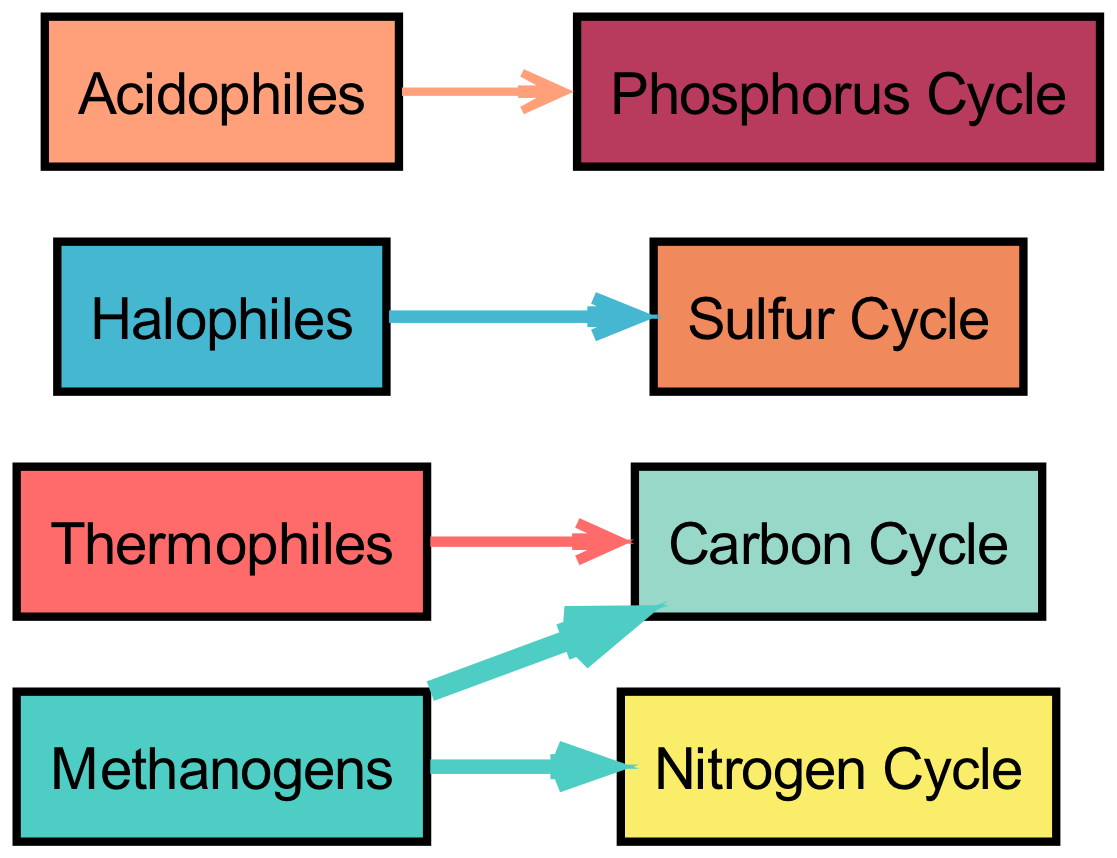What is the total contribution of Methanogens to biogeochemical cycles? The contribution of Methanogens is shown in the diagram as two separate links: 10 for the Carbon Cycle and 7 for the Nitrogen Cycle. Adding these values gives a total contribution of 10 + 7 = 17.
Answer: 17 Which extremophile contributes to the Sulfur Cycle? The diagram indicates that Halophiles directly contribute to the Sulfur Cycle with a value of 6.
Answer: Halophiles How many distinct contributions are made to the Carbon Cycle? From the diagram, there are two sources contributing to the Carbon Cycle: Thermophiles and Methanogens, making it a total of two distinct contributions.
Answer: 2 What is the value of the link from Acidophiles to the Phosphorus Cycle? The diagram specifies that the link from Acidophiles to the Phosphorus Cycle has a value of 4, indicating the strength of this contribution.
Answer: 4 Which extremophile has the highest contribution to the Carbon Cycle? By examining the links, Methanogens contribute 10 to the Carbon Cycle, which is greater than the contribution from Thermophiles, which is only 5. Thus, Methanogens have the highest contribution.
Answer: Methanogens How many edges are there in total connecting extremophiles to cycles? The diagram presents a total of five edges, which represent connections from extremophiles to the various biogeochemical cycles: Thermophiles to Carbon Cycle, Methanogens to Carbon and Nitrogen Cycles, Halophiles to Sulfur Cycle, and Acidophiles to Phosphorus Cycle.
Answer: 5 Which extremophile contributes to the Nitrogen Cycle, and what is the value of this contribution? The link from Methanogens to the Nitrogen Cycle has a value of 7, indicating their contribution to this cycle.
Answer: 7 What is the total contribution of Acidophiles to biogeochemical cycles? Acidophiles contribute only to the Phosphorus Cycle, with a value of 4, indicated in the diagram. Therefore, their total contribution sums up to just 4.
Answer: 4 Which biogeochemical cycle has the highest total contribution from extremophiles? By analyzing the contributions: Carbon Cycle has 10 (Methanogens) + 5 (Thermophiles) = 15; Nitrogen Cycle has 7 (Methanogens); Sulfur Cycle has 6 (Halophiles); Phosphorus Cycle has 4 (Acidophiles). Thus, the Carbon Cycle has the highest total of 15.
Answer: Carbon Cycle 